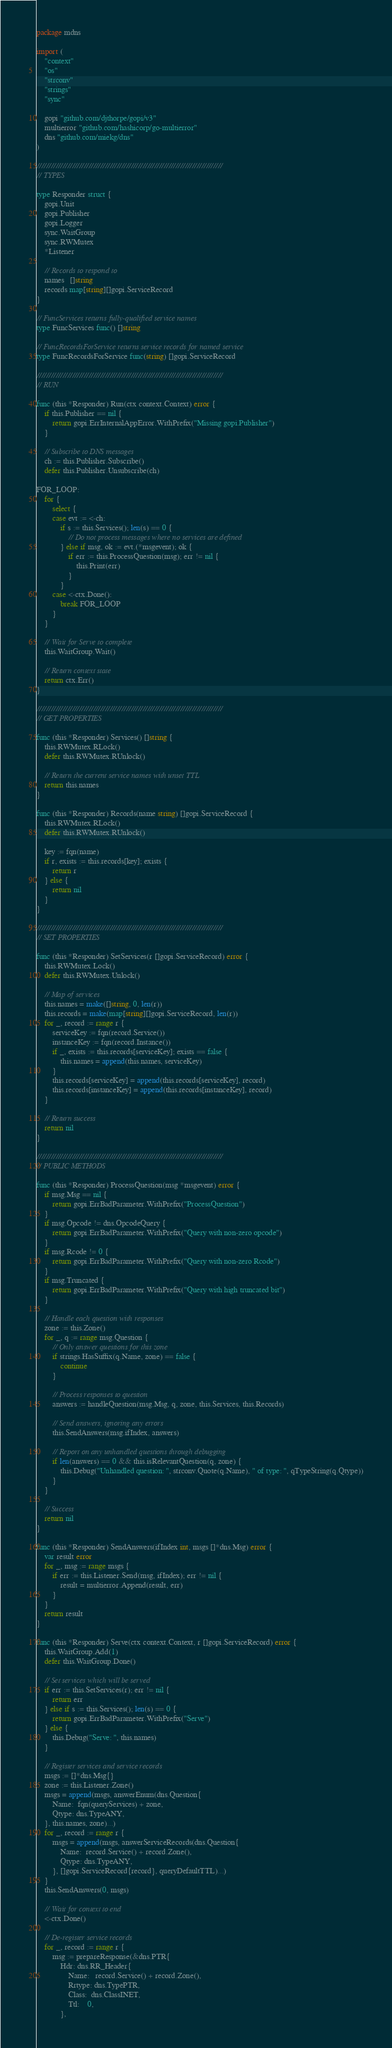Convert code to text. <code><loc_0><loc_0><loc_500><loc_500><_Go_>package mdns

import (
	"context"
	"os"
	"strconv"
	"strings"
	"sync"

	gopi "github.com/djthorpe/gopi/v3"
	multierror "github.com/hashicorp/go-multierror"
	dns "github.com/miekg/dns"
)

///////////////////////////////////////////////////////////////////////////////
// TYPES

type Responder struct {
	gopi.Unit
	gopi.Publisher
	gopi.Logger
	sync.WaitGroup
	sync.RWMutex
	*Listener

	// Records to respond to
	names   []string
	records map[string][]gopi.ServiceRecord
}

// FuncServices returns fully-qualified service names
type FuncServices func() []string

// FuncRecordsForService returns service records for named service
type FuncRecordsForService func(string) []gopi.ServiceRecord

///////////////////////////////////////////////////////////////////////////////
// RUN

func (this *Responder) Run(ctx context.Context) error {
	if this.Publisher == nil {
		return gopi.ErrInternalAppError.WithPrefix("Missing gopi.Publisher")
	}

	// Subscribe to DNS messages
	ch := this.Publisher.Subscribe()
	defer this.Publisher.Unsubscribe(ch)

FOR_LOOP:
	for {
		select {
		case evt := <-ch:
			if s := this.Services(); len(s) == 0 {
				// Do not process messages where no services are defined
			} else if msg, ok := evt.(*msgevent); ok {
				if err := this.ProcessQuestion(msg); err != nil {
					this.Print(err)
				}
			}
		case <-ctx.Done():
			break FOR_LOOP
		}
	}

	// Wait for Serve to complete
	this.WaitGroup.Wait()

	// Return context state
	return ctx.Err()
}

///////////////////////////////////////////////////////////////////////////////
// GET PROPERTIES

func (this *Responder) Services() []string {
	this.RWMutex.RLock()
	defer this.RWMutex.RUnlock()

	// Return the current service names with unset TTL
	return this.names
}

func (this *Responder) Records(name string) []gopi.ServiceRecord {
	this.RWMutex.RLock()
	defer this.RWMutex.RUnlock()

	key := fqn(name)
	if r, exists := this.records[key]; exists {
		return r
	} else {
		return nil
	}
}

///////////////////////////////////////////////////////////////////////////////
// SET PROPERTIES

func (this *Responder) SetServices(r []gopi.ServiceRecord) error {
	this.RWMutex.Lock()
	defer this.RWMutex.Unlock()

	// Map of services
	this.names = make([]string, 0, len(r))
	this.records = make(map[string][]gopi.ServiceRecord, len(r))
	for _, record := range r {
		serviceKey := fqn(record.Service())
		instanceKey := fqn(record.Instance())
		if _, exists := this.records[serviceKey]; exists == false {
			this.names = append(this.names, serviceKey)
		}
		this.records[serviceKey] = append(this.records[serviceKey], record)
		this.records[instanceKey] = append(this.records[instanceKey], record)
	}

	// Return success
	return nil
}

///////////////////////////////////////////////////////////////////////////////
// PUBLIC METHODS

func (this *Responder) ProcessQuestion(msg *msgevent) error {
	if msg.Msg == nil {
		return gopi.ErrBadParameter.WithPrefix("ProcessQuestion")
	}
	if msg.Opcode != dns.OpcodeQuery {
		return gopi.ErrBadParameter.WithPrefix("Query with non-zero opcode")
	}
	if msg.Rcode != 0 {
		return gopi.ErrBadParameter.WithPrefix("Query with non-zero Rcode")
	}
	if msg.Truncated {
		return gopi.ErrBadParameter.WithPrefix("Query with high truncated bit")
	}

	// Handle each question with responses
	zone := this.Zone()
	for _, q := range msg.Question {
		// Only answer questions for this zone
		if strings.HasSuffix(q.Name, zone) == false {
			continue
		}

		// Process responses to question
		answers := handleQuestion(msg.Msg, q, zone, this.Services, this.Records)

		// Send answers, ignoring any errors
		this.SendAnswers(msg.ifIndex, answers)

		// Report on any unhandled questions through debugging
		if len(answers) == 0 && this.isRelevantQuestion(q, zone) {
			this.Debug("Unhandled question: ", strconv.Quote(q.Name), " of type: ", qTypeString(q.Qtype))
		}
	}

	// Success
	return nil
}

func (this *Responder) SendAnswers(ifIndex int, msgs []*dns.Msg) error {
	var result error
	for _, msg := range msgs {
		if err := this.Listener.Send(msg, ifIndex); err != nil {
			result = multierror.Append(result, err)
		}
	}
	return result
}

func (this *Responder) Serve(ctx context.Context, r []gopi.ServiceRecord) error {
	this.WaitGroup.Add(1)
	defer this.WaitGroup.Done()

	// Set services which will be served
	if err := this.SetServices(r); err != nil {
		return err
	} else if s := this.Services(); len(s) == 0 {
		return gopi.ErrBadParameter.WithPrefix("Serve")
	} else {
		this.Debug("Serve: ", this.names)
	}

	// Register services and service records
	msgs := []*dns.Msg{}
	zone := this.Listener.Zone()
	msgs = append(msgs, answerEnum(dns.Question{
		Name:  fqn(queryServices) + zone,
		Qtype: dns.TypeANY,
	}, this.names, zone)...)
	for _, record := range r {
		msgs = append(msgs, answerServiceRecords(dns.Question{
			Name:  record.Service() + record.Zone(),
			Qtype: dns.TypeANY,
		}, []gopi.ServiceRecord{record}, queryDefaultTTL)...)
	}
	this.SendAnswers(0, msgs)

	// Wait for context to end
	<-ctx.Done()

	// De-register service records
	for _, record := range r {
		msg := prepareResponse(&dns.PTR{
			Hdr: dns.RR_Header{
				Name:   record.Service() + record.Zone(),
				Rrtype: dns.TypePTR,
				Class:  dns.ClassINET,
				Ttl:    0,
			},</code> 